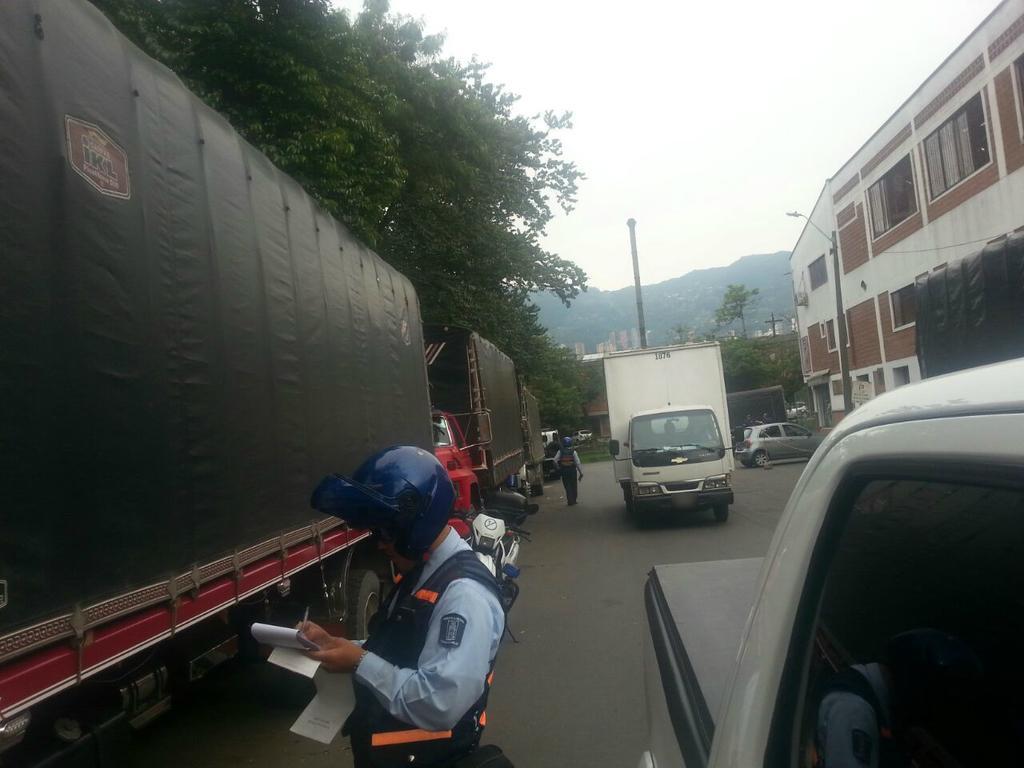Can you describe this image briefly? There is one person standing and holding a pen and paper. There are vehicles present in the background. We can see trees in the middle of this image and the sky is at the top of this image. 